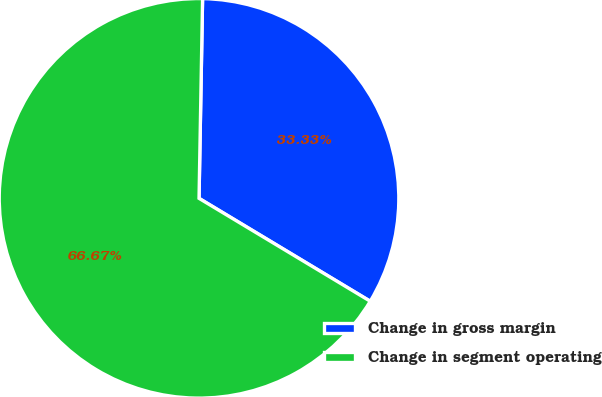Convert chart. <chart><loc_0><loc_0><loc_500><loc_500><pie_chart><fcel>Change in gross margin<fcel>Change in segment operating<nl><fcel>33.33%<fcel>66.67%<nl></chart> 